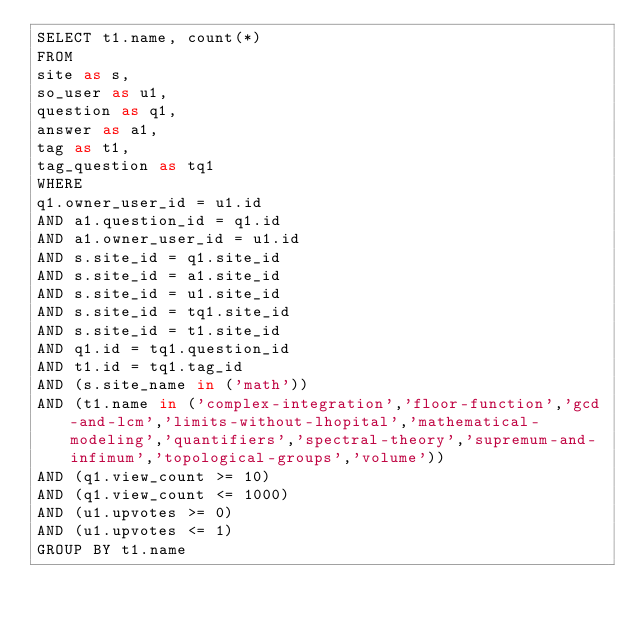<code> <loc_0><loc_0><loc_500><loc_500><_SQL_>SELECT t1.name, count(*)
FROM
site as s,
so_user as u1,
question as q1,
answer as a1,
tag as t1,
tag_question as tq1
WHERE
q1.owner_user_id = u1.id
AND a1.question_id = q1.id
AND a1.owner_user_id = u1.id
AND s.site_id = q1.site_id
AND s.site_id = a1.site_id
AND s.site_id = u1.site_id
AND s.site_id = tq1.site_id
AND s.site_id = t1.site_id
AND q1.id = tq1.question_id
AND t1.id = tq1.tag_id
AND (s.site_name in ('math'))
AND (t1.name in ('complex-integration','floor-function','gcd-and-lcm','limits-without-lhopital','mathematical-modeling','quantifiers','spectral-theory','supremum-and-infimum','topological-groups','volume'))
AND (q1.view_count >= 10)
AND (q1.view_count <= 1000)
AND (u1.upvotes >= 0)
AND (u1.upvotes <= 1)
GROUP BY t1.name</code> 